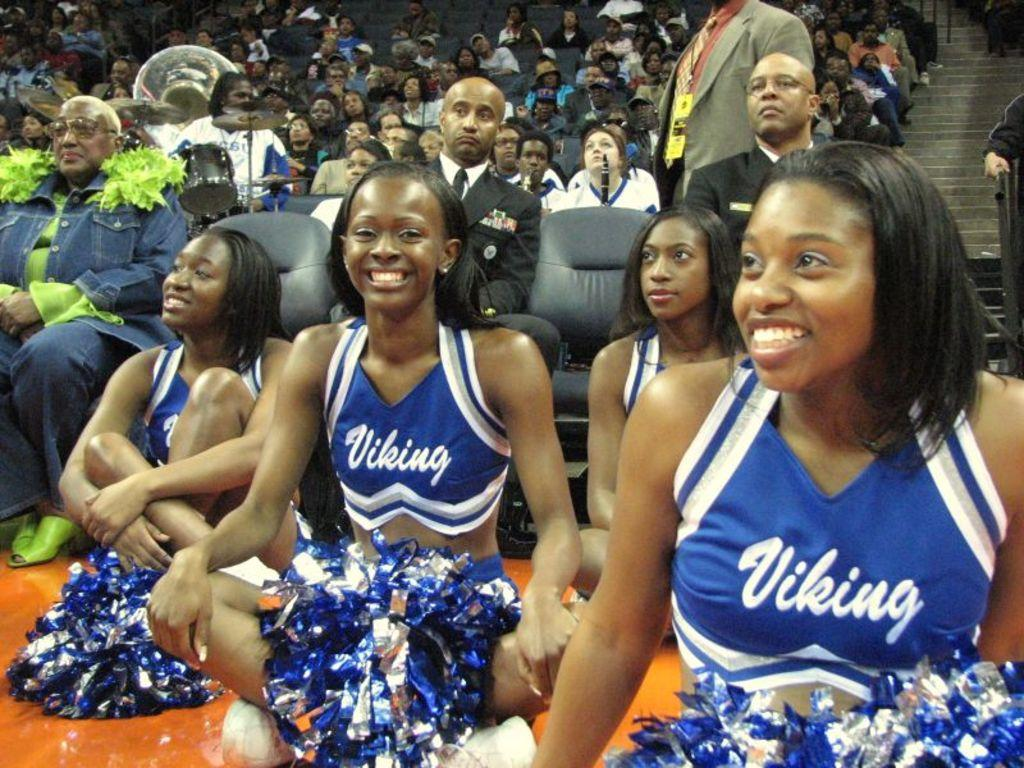<image>
Give a short and clear explanation of the subsequent image. Several Viking cheerleaders sit on the floor in front of many people sitting in seats. 